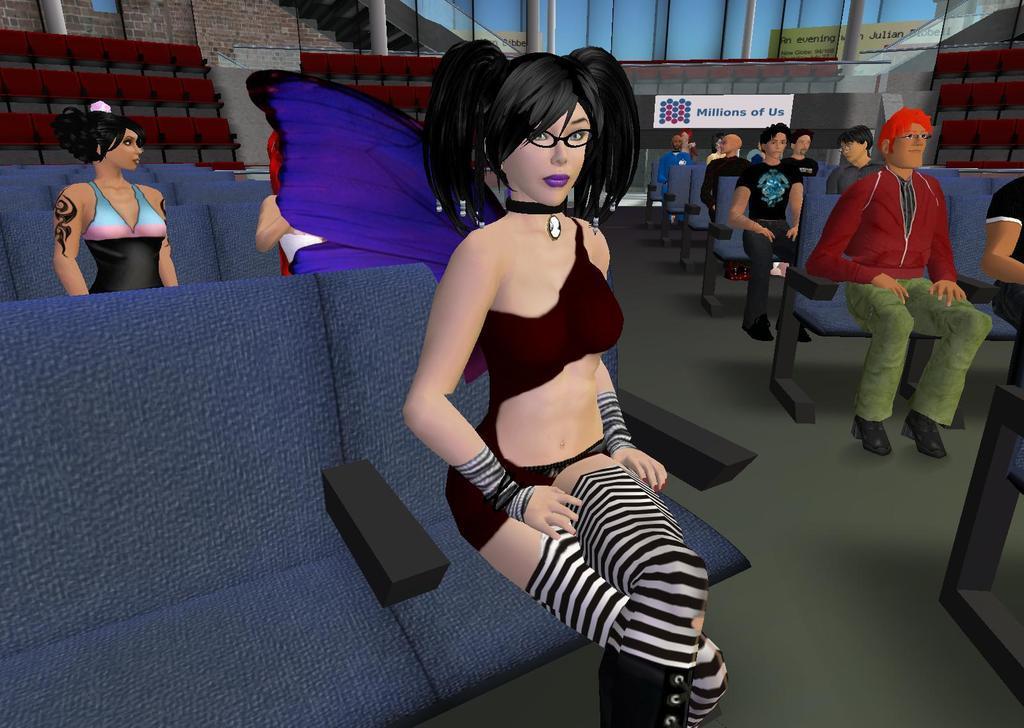Could you give a brief overview of what you see in this image? This is an animated picture. In this image, we can see people sitting on the seats. In the bottom right corner, there is an object on the floor. In the background, there are seats, wall, pillars, banners and glass objects. 